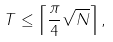Convert formula to latex. <formula><loc_0><loc_0><loc_500><loc_500>T \leq \left \lceil \frac { \pi } { 4 } \sqrt { N } \right \rceil ,</formula> 